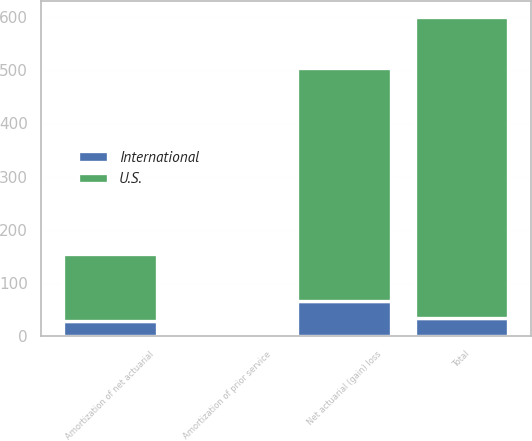Convert chart to OTSL. <chart><loc_0><loc_0><loc_500><loc_500><stacked_bar_chart><ecel><fcel>Net actuarial (gain) loss<fcel>Amortization of net actuarial<fcel>Amortization of prior service<fcel>Total<nl><fcel>U.S.<fcel>437.6<fcel>127.5<fcel>2.9<fcel>565.4<nl><fcel>International<fcel>67.2<fcel>27.9<fcel>0.2<fcel>34.7<nl></chart> 